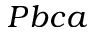<formula> <loc_0><loc_0><loc_500><loc_500>P b c a</formula> 